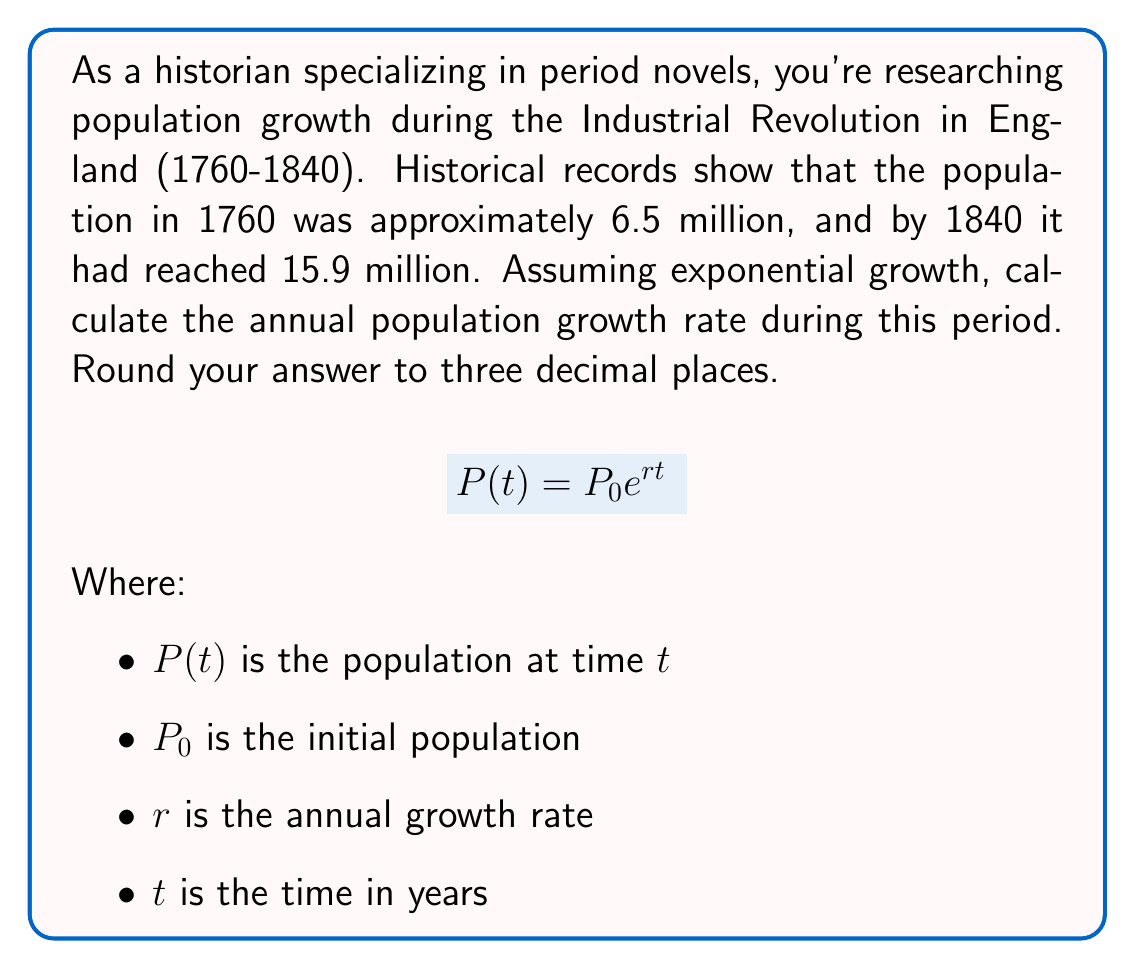Help me with this question. To solve this problem, we'll use the exponential growth formula and follow these steps:

1. Identify the known variables:
   $P_0 = 6.5$ million (population in 1760)
   $P(t) = 15.9$ million (population in 1840)
   $t = 80$ years (time period from 1760 to 1840)

2. Plug these values into the exponential growth formula:
   $$15.9 = 6.5 e^{80r}$$

3. Divide both sides by 6.5:
   $$\frac{15.9}{6.5} = e^{80r}$$

4. Take the natural logarithm of both sides:
   $$\ln(\frac{15.9}{6.5}) = 80r$$

5. Solve for $r$:
   $$r = \frac{\ln(\frac{15.9}{6.5})}{80}$$

6. Calculate the value:
   $$r = \frac{\ln(2.446153846)}{80} = \frac{0.894316063}{80} = 0.011178951$$

7. Round to three decimal places:
   $r \approx 0.011$

Therefore, the annual population growth rate during the Industrial Revolution in England was approximately 0.011 or 1.1% per year.
Answer: 0.011 